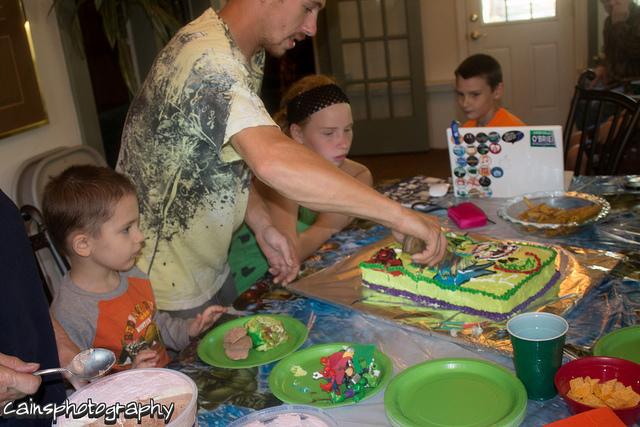Is this most likely a birthday party?
Answer briefly. Yes. What does it say in the corner of the picture?
Quick response, please. Cainsphotography. What utensil is in the far left bottom corner?
Be succinct. Spoon. 